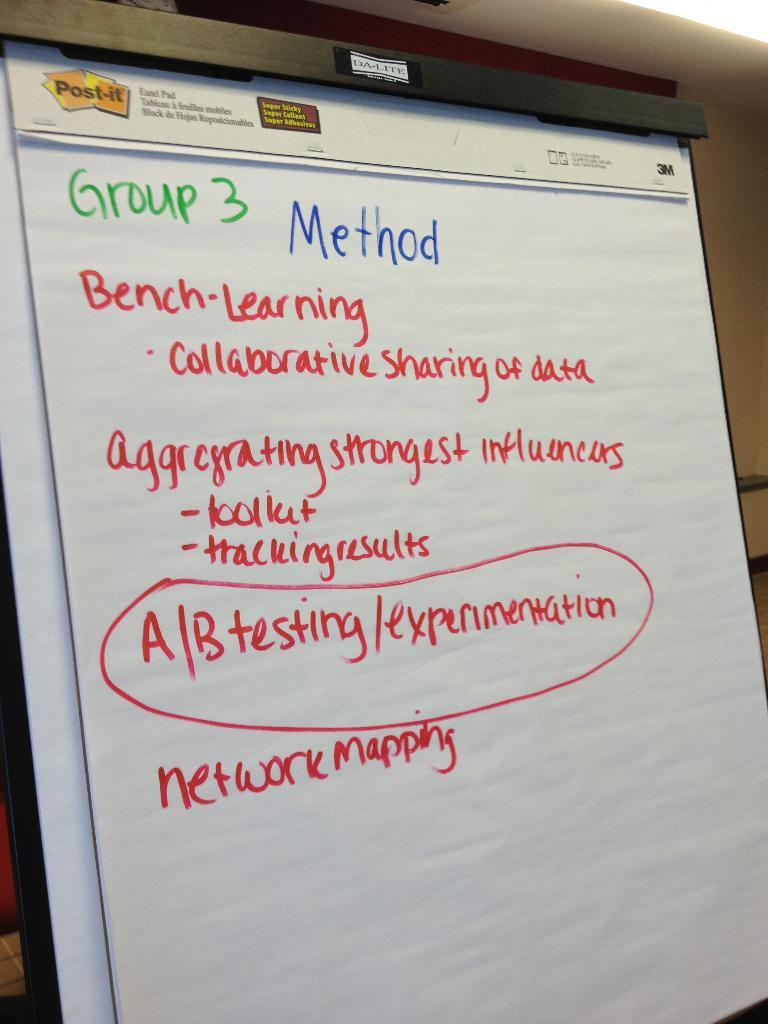Provide a one-sentence caption for the provided image. A large paper note pad made by Post-it with green, blue and red text outlining Group 3's methods for work to be done. 